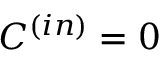<formula> <loc_0><loc_0><loc_500><loc_500>C ^ { ( i n ) } = 0</formula> 